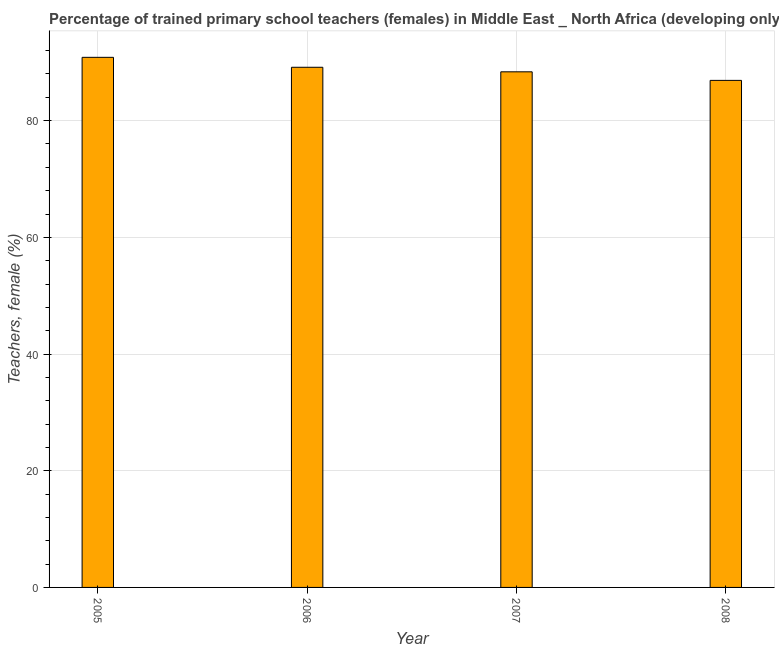What is the title of the graph?
Your answer should be very brief. Percentage of trained primary school teachers (females) in Middle East _ North Africa (developing only). What is the label or title of the X-axis?
Offer a very short reply. Year. What is the label or title of the Y-axis?
Provide a succinct answer. Teachers, female (%). What is the percentage of trained female teachers in 2008?
Your answer should be very brief. 86.9. Across all years, what is the maximum percentage of trained female teachers?
Offer a very short reply. 90.85. Across all years, what is the minimum percentage of trained female teachers?
Give a very brief answer. 86.9. In which year was the percentage of trained female teachers maximum?
Ensure brevity in your answer.  2005. In which year was the percentage of trained female teachers minimum?
Make the answer very short. 2008. What is the sum of the percentage of trained female teachers?
Your answer should be compact. 355.28. What is the difference between the percentage of trained female teachers in 2005 and 2008?
Offer a very short reply. 3.95. What is the average percentage of trained female teachers per year?
Offer a terse response. 88.82. What is the median percentage of trained female teachers?
Give a very brief answer. 88.76. Do a majority of the years between 2006 and 2007 (inclusive) have percentage of trained female teachers greater than 8 %?
Offer a terse response. Yes. What is the ratio of the percentage of trained female teachers in 2006 to that in 2007?
Keep it short and to the point. 1.01. Is the percentage of trained female teachers in 2005 less than that in 2006?
Provide a short and direct response. No. What is the difference between the highest and the second highest percentage of trained female teachers?
Your response must be concise. 1.7. Is the sum of the percentage of trained female teachers in 2006 and 2007 greater than the maximum percentage of trained female teachers across all years?
Keep it short and to the point. Yes. What is the difference between the highest and the lowest percentage of trained female teachers?
Offer a terse response. 3.95. In how many years, is the percentage of trained female teachers greater than the average percentage of trained female teachers taken over all years?
Your answer should be compact. 2. How many bars are there?
Make the answer very short. 4. Are the values on the major ticks of Y-axis written in scientific E-notation?
Provide a short and direct response. No. What is the Teachers, female (%) in 2005?
Make the answer very short. 90.85. What is the Teachers, female (%) in 2006?
Your answer should be compact. 89.15. What is the Teachers, female (%) in 2007?
Your answer should be very brief. 88.37. What is the Teachers, female (%) of 2008?
Give a very brief answer. 86.9. What is the difference between the Teachers, female (%) in 2005 and 2006?
Make the answer very short. 1.7. What is the difference between the Teachers, female (%) in 2005 and 2007?
Your response must be concise. 2.48. What is the difference between the Teachers, female (%) in 2005 and 2008?
Ensure brevity in your answer.  3.95. What is the difference between the Teachers, female (%) in 2006 and 2007?
Provide a short and direct response. 0.78. What is the difference between the Teachers, female (%) in 2006 and 2008?
Offer a very short reply. 2.25. What is the difference between the Teachers, female (%) in 2007 and 2008?
Provide a succinct answer. 1.47. What is the ratio of the Teachers, female (%) in 2005 to that in 2007?
Ensure brevity in your answer.  1.03. What is the ratio of the Teachers, female (%) in 2005 to that in 2008?
Give a very brief answer. 1.04. 